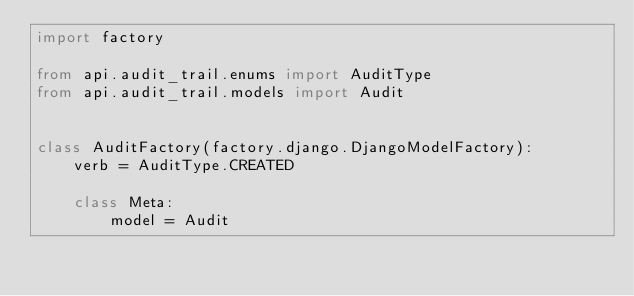Convert code to text. <code><loc_0><loc_0><loc_500><loc_500><_Python_>import factory

from api.audit_trail.enums import AuditType
from api.audit_trail.models import Audit


class AuditFactory(factory.django.DjangoModelFactory):
    verb = AuditType.CREATED

    class Meta:
        model = Audit
</code> 